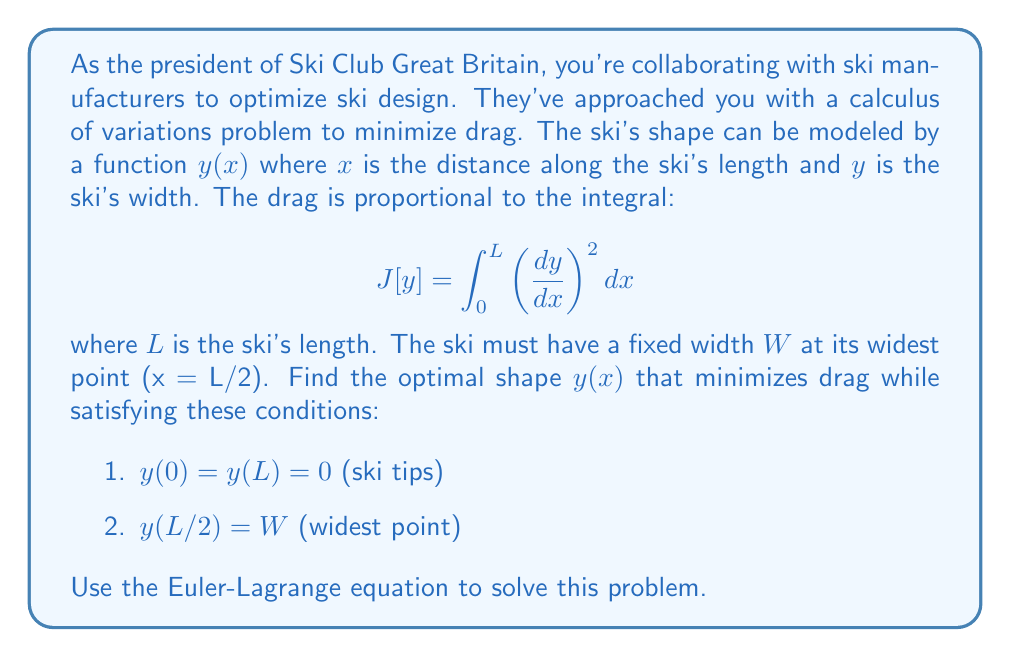Could you help me with this problem? Let's approach this step-by-step using calculus of variations:

1) The functional to be minimized is:

   $$ J[y] = \int_0^L \left(\frac{dy}{dx}\right)^2 dx $$

2) The Euler-Lagrange equation for this problem is:

   $$ \frac{\partial F}{\partial y} - \frac{d}{dx}\left(\frac{\partial F}{\partial y'}\right) = 0 $$

   where $F = (y')^2$ and $y' = \frac{dy}{dx}$

3) Applying the Euler-Lagrange equation:

   $$ \frac{\partial F}{\partial y} = 0 $$
   $$ \frac{\partial F}{\partial y'} = 2y' $$
   $$ \frac{d}{dx}\left(\frac{\partial F}{\partial y'}\right) = 2y'' $$

4) Substituting into the Euler-Lagrange equation:

   $$ 0 - 2y'' = 0 $$
   $$ y'' = 0 $$

5) Integrating twice:

   $$ y' = C_1 $$
   $$ y = C_1x + C_2 $$

6) Now, we apply the boundary conditions:

   $y(0) = 0$ implies $C_2 = 0$
   $y(L) = 0$ implies $C_1L + C_2 = 0$ or $C_1L = 0$
   $y(L/2) = W$ implies $C_1(L/2) = W$

7) From the last condition:

   $$ C_1 = \frac{2W}{L} $$

8) Therefore, the optimal shape is:

   $$ y(x) = \frac{2W}{L}x \quad \text{for } 0 \leq x \leq L/2 $$
   $$ y(x) = \frac{2W}{L}(L-x) \quad \text{for } L/2 \leq x \leq L $$

This represents a triangular shape with the peak at x = L/2.
Answer: The optimal shape to minimize drag is a triangular profile:

$$ y(x) = \begin{cases}
\frac{2W}{L}x & \text{for } 0 \leq x \leq L/2 \\
\frac{2W}{L}(L-x) & \text{for } L/2 \leq x \leq L
\end{cases} $$

where $W$ is the maximum width and $L$ is the length of the ski. 